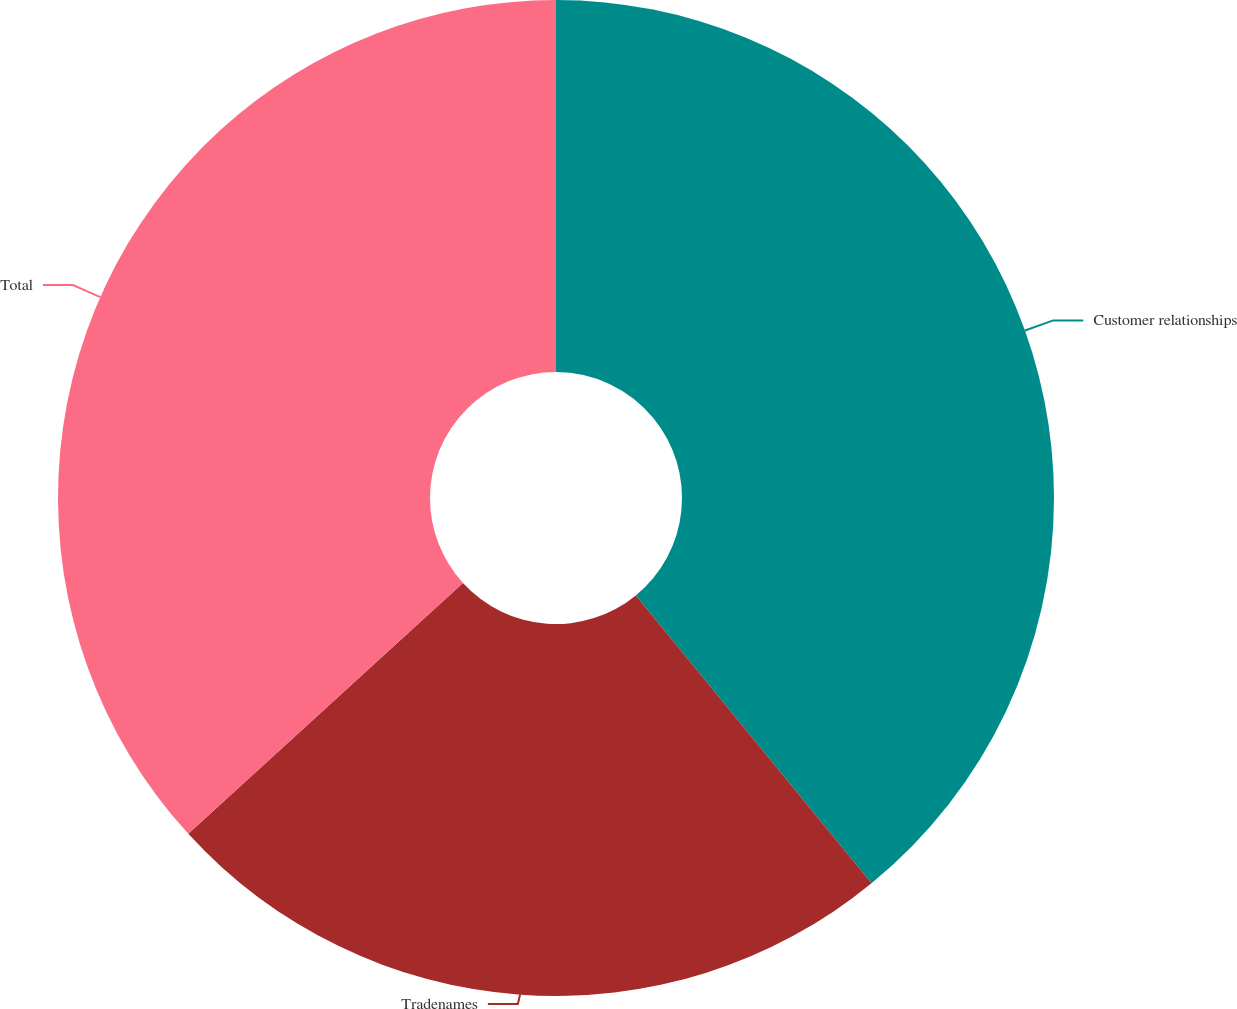Convert chart. <chart><loc_0><loc_0><loc_500><loc_500><pie_chart><fcel>Customer relationships<fcel>Tradenames<fcel>Total<nl><fcel>39.08%<fcel>24.14%<fcel>36.78%<nl></chart> 